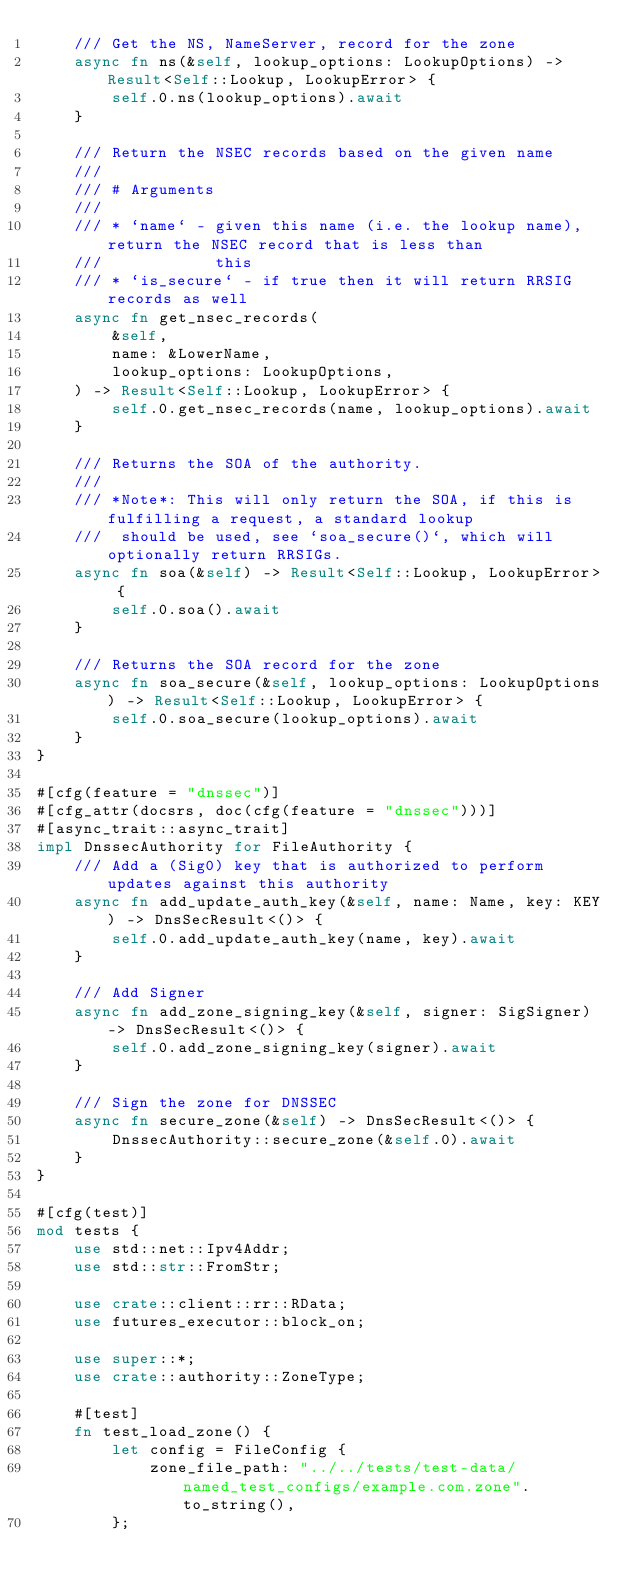<code> <loc_0><loc_0><loc_500><loc_500><_Rust_>    /// Get the NS, NameServer, record for the zone
    async fn ns(&self, lookup_options: LookupOptions) -> Result<Self::Lookup, LookupError> {
        self.0.ns(lookup_options).await
    }

    /// Return the NSEC records based on the given name
    ///
    /// # Arguments
    ///
    /// * `name` - given this name (i.e. the lookup name), return the NSEC record that is less than
    ///            this
    /// * `is_secure` - if true then it will return RRSIG records as well
    async fn get_nsec_records(
        &self,
        name: &LowerName,
        lookup_options: LookupOptions,
    ) -> Result<Self::Lookup, LookupError> {
        self.0.get_nsec_records(name, lookup_options).await
    }

    /// Returns the SOA of the authority.
    ///
    /// *Note*: This will only return the SOA, if this is fulfilling a request, a standard lookup
    ///  should be used, see `soa_secure()`, which will optionally return RRSIGs.
    async fn soa(&self) -> Result<Self::Lookup, LookupError> {
        self.0.soa().await
    }

    /// Returns the SOA record for the zone
    async fn soa_secure(&self, lookup_options: LookupOptions) -> Result<Self::Lookup, LookupError> {
        self.0.soa_secure(lookup_options).await
    }
}

#[cfg(feature = "dnssec")]
#[cfg_attr(docsrs, doc(cfg(feature = "dnssec")))]
#[async_trait::async_trait]
impl DnssecAuthority for FileAuthority {
    /// Add a (Sig0) key that is authorized to perform updates against this authority
    async fn add_update_auth_key(&self, name: Name, key: KEY) -> DnsSecResult<()> {
        self.0.add_update_auth_key(name, key).await
    }

    /// Add Signer
    async fn add_zone_signing_key(&self, signer: SigSigner) -> DnsSecResult<()> {
        self.0.add_zone_signing_key(signer).await
    }

    /// Sign the zone for DNSSEC
    async fn secure_zone(&self) -> DnsSecResult<()> {
        DnssecAuthority::secure_zone(&self.0).await
    }
}

#[cfg(test)]
mod tests {
    use std::net::Ipv4Addr;
    use std::str::FromStr;

    use crate::client::rr::RData;
    use futures_executor::block_on;

    use super::*;
    use crate::authority::ZoneType;

    #[test]
    fn test_load_zone() {
        let config = FileConfig {
            zone_file_path: "../../tests/test-data/named_test_configs/example.com.zone".to_string(),
        };</code> 